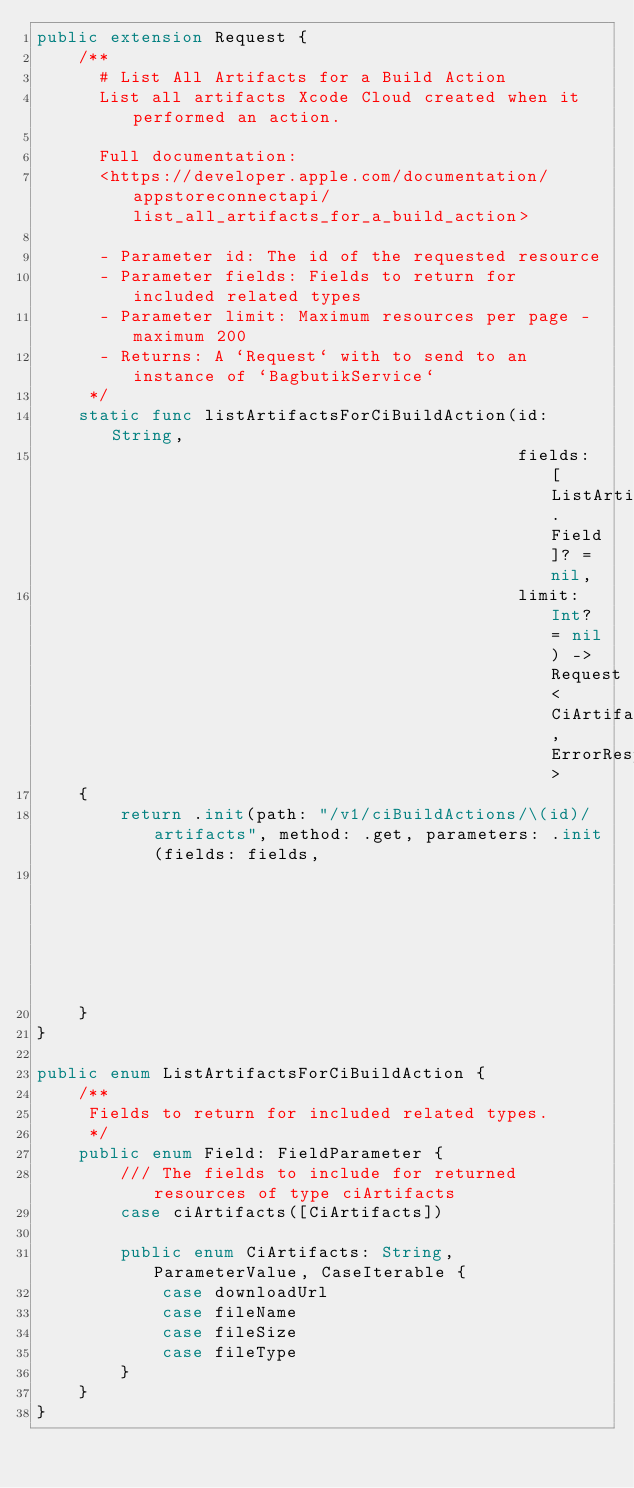Convert code to text. <code><loc_0><loc_0><loc_500><loc_500><_Swift_>public extension Request {
    /**
      # List All Artifacts for a Build Action
      List all artifacts Xcode Cloud created when it performed an action.

      Full documentation:
      <https://developer.apple.com/documentation/appstoreconnectapi/list_all_artifacts_for_a_build_action>

      - Parameter id: The id of the requested resource
      - Parameter fields: Fields to return for included related types
      - Parameter limit: Maximum resources per page - maximum 200
      - Returns: A `Request` with to send to an instance of `BagbutikService`
     */
    static func listArtifactsForCiBuildAction(id: String,
                                              fields: [ListArtifactsForCiBuildAction.Field]? = nil,
                                              limit: Int? = nil) -> Request<CiArtifactsResponse, ErrorResponse>
    {
        return .init(path: "/v1/ciBuildActions/\(id)/artifacts", method: .get, parameters: .init(fields: fields,
                                                                                                 limit: limit))
    }
}

public enum ListArtifactsForCiBuildAction {
    /**
     Fields to return for included related types.
     */
    public enum Field: FieldParameter {
        /// The fields to include for returned resources of type ciArtifacts
        case ciArtifacts([CiArtifacts])

        public enum CiArtifacts: String, ParameterValue, CaseIterable {
            case downloadUrl
            case fileName
            case fileSize
            case fileType
        }
    }
}
</code> 